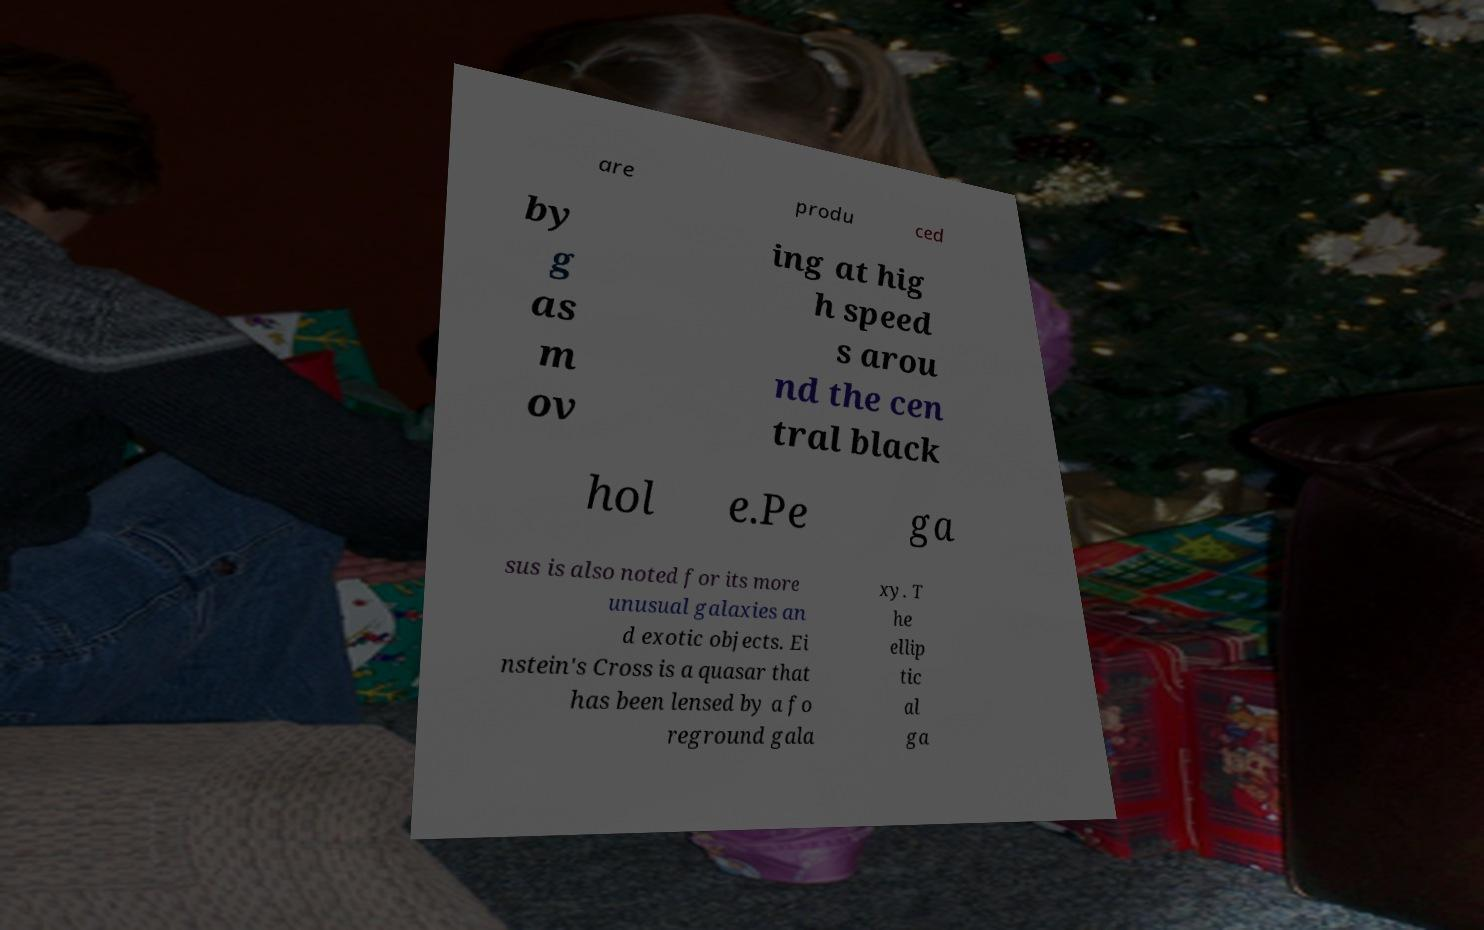Can you read and provide the text displayed in the image?This photo seems to have some interesting text. Can you extract and type it out for me? are produ ced by g as m ov ing at hig h speed s arou nd the cen tral black hol e.Pe ga sus is also noted for its more unusual galaxies an d exotic objects. Ei nstein's Cross is a quasar that has been lensed by a fo reground gala xy. T he ellip tic al ga 